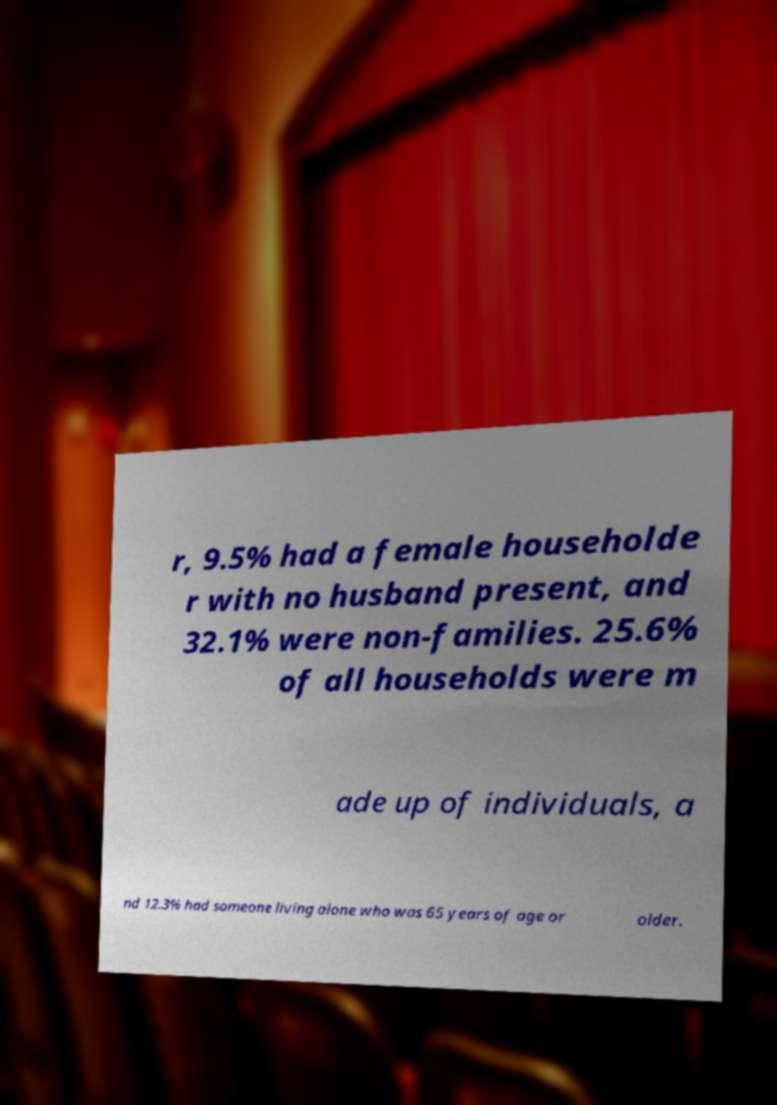Can you accurately transcribe the text from the provided image for me? r, 9.5% had a female householde r with no husband present, and 32.1% were non-families. 25.6% of all households were m ade up of individuals, a nd 12.3% had someone living alone who was 65 years of age or older. 